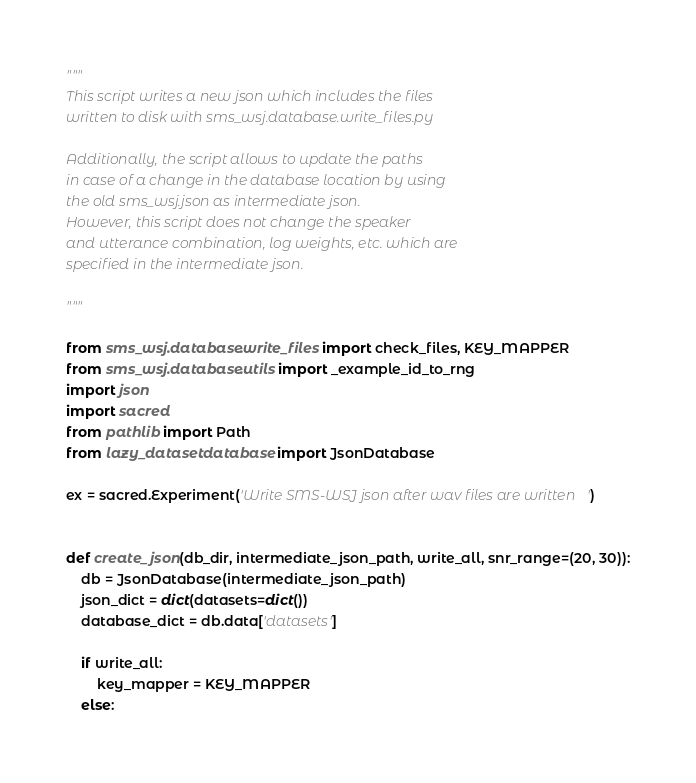Convert code to text. <code><loc_0><loc_0><loc_500><loc_500><_Python_>"""
This script writes a new json which includes the files
written to disk with sms_wsj.database.write_files.py

Additionally, the script allows to update the paths
in case of a change in the database location by using
the old sms_wsj.json as intermediate json.
However, this script does not change the speaker
and utterance combination, log weights, etc. which are
specified in the intermediate json.

"""

from sms_wsj.database.write_files import check_files, KEY_MAPPER
from sms_wsj.database.utils import _example_id_to_rng
import json
import sacred
from pathlib import Path
from lazy_dataset.database import JsonDatabase

ex = sacred.Experiment('Write SMS-WSJ json after wav files are written')


def create_json(db_dir, intermediate_json_path, write_all, snr_range=(20, 30)):
    db = JsonDatabase(intermediate_json_path)
    json_dict = dict(datasets=dict())
    database_dict = db.data['datasets']

    if write_all:
        key_mapper = KEY_MAPPER
    else:</code> 